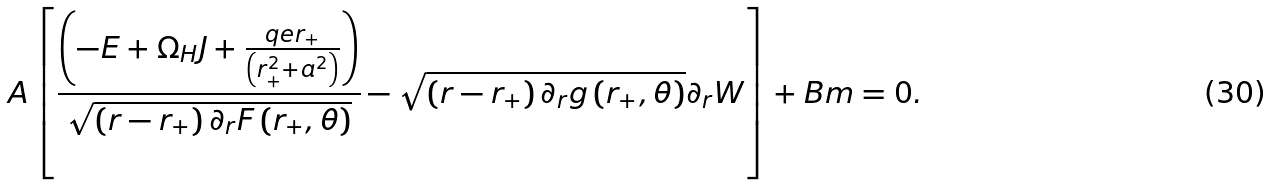Convert formula to latex. <formula><loc_0><loc_0><loc_500><loc_500>A \left [ \frac { \left ( - E + \Omega _ { H } J + \frac { q e r _ { + } } { \left ( r _ { + } ^ { 2 } + a ^ { 2 } \right ) } \right ) } { \sqrt { \left ( r - r _ { + } \right ) \partial _ { r } F \left ( r _ { + } , \theta \right ) } } - \sqrt { \left ( r - r _ { + } \right ) \partial _ { r } g \left ( r _ { + } , \theta \right ) } \partial _ { r } W \right ] + B m = 0 .</formula> 